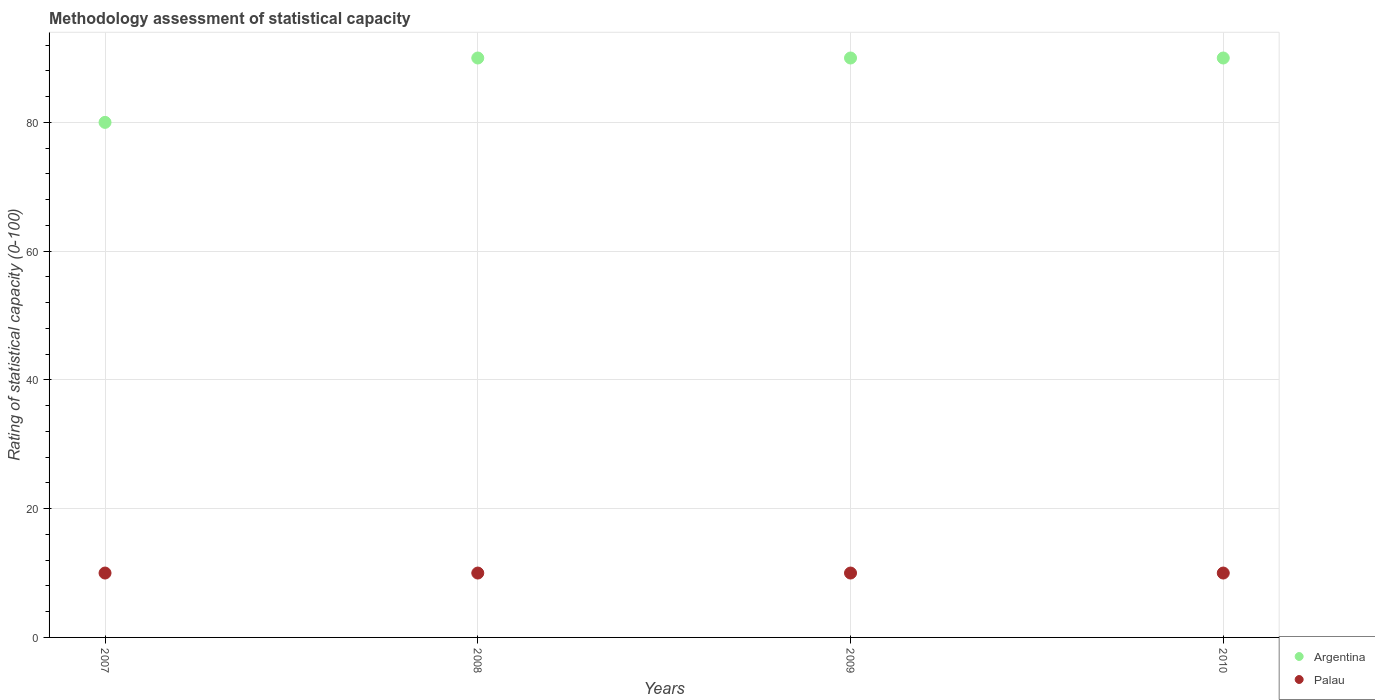How many different coloured dotlines are there?
Keep it short and to the point. 2. What is the rating of statistical capacity in Argentina in 2009?
Make the answer very short. 90. Across all years, what is the maximum rating of statistical capacity in Palau?
Your answer should be very brief. 10. In which year was the rating of statistical capacity in Palau maximum?
Your response must be concise. 2007. In which year was the rating of statistical capacity in Palau minimum?
Offer a very short reply. 2007. What is the total rating of statistical capacity in Argentina in the graph?
Offer a terse response. 350. What is the difference between the rating of statistical capacity in Argentina in 2007 and that in 2009?
Make the answer very short. -10. What is the difference between the rating of statistical capacity in Palau in 2008 and the rating of statistical capacity in Argentina in 2010?
Provide a short and direct response. -80. What is the ratio of the rating of statistical capacity in Argentina in 2007 to that in 2008?
Provide a short and direct response. 0.89. Is the difference between the rating of statistical capacity in Argentina in 2008 and 2010 greater than the difference between the rating of statistical capacity in Palau in 2008 and 2010?
Your answer should be compact. No. What is the difference between the highest and the second highest rating of statistical capacity in Palau?
Provide a short and direct response. 0. What is the difference between the highest and the lowest rating of statistical capacity in Argentina?
Offer a very short reply. 10. In how many years, is the rating of statistical capacity in Argentina greater than the average rating of statistical capacity in Argentina taken over all years?
Provide a short and direct response. 3. Is the sum of the rating of statistical capacity in Palau in 2009 and 2010 greater than the maximum rating of statistical capacity in Argentina across all years?
Provide a short and direct response. No. Is the rating of statistical capacity in Palau strictly greater than the rating of statistical capacity in Argentina over the years?
Keep it short and to the point. No. How many years are there in the graph?
Give a very brief answer. 4. What is the difference between two consecutive major ticks on the Y-axis?
Make the answer very short. 20. Are the values on the major ticks of Y-axis written in scientific E-notation?
Your answer should be compact. No. Does the graph contain any zero values?
Ensure brevity in your answer.  No. Does the graph contain grids?
Offer a very short reply. Yes. Where does the legend appear in the graph?
Your answer should be very brief. Bottom right. How are the legend labels stacked?
Provide a succinct answer. Vertical. What is the title of the graph?
Keep it short and to the point. Methodology assessment of statistical capacity. What is the label or title of the Y-axis?
Provide a short and direct response. Rating of statistical capacity (0-100). What is the Rating of statistical capacity (0-100) of Argentina in 2008?
Make the answer very short. 90. What is the Rating of statistical capacity (0-100) in Argentina in 2010?
Provide a succinct answer. 90. Across all years, what is the maximum Rating of statistical capacity (0-100) in Argentina?
Your response must be concise. 90. Across all years, what is the maximum Rating of statistical capacity (0-100) in Palau?
Your answer should be very brief. 10. Across all years, what is the minimum Rating of statistical capacity (0-100) of Argentina?
Provide a short and direct response. 80. Across all years, what is the minimum Rating of statistical capacity (0-100) of Palau?
Offer a very short reply. 10. What is the total Rating of statistical capacity (0-100) of Argentina in the graph?
Offer a very short reply. 350. What is the total Rating of statistical capacity (0-100) in Palau in the graph?
Your answer should be very brief. 40. What is the difference between the Rating of statistical capacity (0-100) in Argentina in 2007 and that in 2010?
Your response must be concise. -10. What is the difference between the Rating of statistical capacity (0-100) in Palau in 2007 and that in 2010?
Provide a succinct answer. 0. What is the difference between the Rating of statistical capacity (0-100) in Argentina in 2008 and that in 2009?
Ensure brevity in your answer.  0. What is the difference between the Rating of statistical capacity (0-100) in Palau in 2008 and that in 2009?
Provide a succinct answer. 0. What is the difference between the Rating of statistical capacity (0-100) of Argentina in 2008 and that in 2010?
Give a very brief answer. 0. What is the difference between the Rating of statistical capacity (0-100) of Palau in 2008 and that in 2010?
Your response must be concise. 0. What is the difference between the Rating of statistical capacity (0-100) of Palau in 2009 and that in 2010?
Keep it short and to the point. 0. What is the difference between the Rating of statistical capacity (0-100) of Argentina in 2007 and the Rating of statistical capacity (0-100) of Palau in 2008?
Provide a short and direct response. 70. What is the difference between the Rating of statistical capacity (0-100) in Argentina in 2007 and the Rating of statistical capacity (0-100) in Palau in 2009?
Offer a very short reply. 70. What is the difference between the Rating of statistical capacity (0-100) of Argentina in 2008 and the Rating of statistical capacity (0-100) of Palau in 2010?
Keep it short and to the point. 80. What is the average Rating of statistical capacity (0-100) in Argentina per year?
Offer a very short reply. 87.5. What is the average Rating of statistical capacity (0-100) in Palau per year?
Make the answer very short. 10. In the year 2007, what is the difference between the Rating of statistical capacity (0-100) in Argentina and Rating of statistical capacity (0-100) in Palau?
Ensure brevity in your answer.  70. In the year 2009, what is the difference between the Rating of statistical capacity (0-100) of Argentina and Rating of statistical capacity (0-100) of Palau?
Offer a very short reply. 80. What is the ratio of the Rating of statistical capacity (0-100) of Argentina in 2007 to that in 2009?
Ensure brevity in your answer.  0.89. What is the ratio of the Rating of statistical capacity (0-100) of Palau in 2007 to that in 2009?
Provide a succinct answer. 1. What is the ratio of the Rating of statistical capacity (0-100) of Argentina in 2007 to that in 2010?
Provide a short and direct response. 0.89. What is the ratio of the Rating of statistical capacity (0-100) of Argentina in 2009 to that in 2010?
Keep it short and to the point. 1. What is the difference between the highest and the second highest Rating of statistical capacity (0-100) of Argentina?
Your answer should be compact. 0. What is the difference between the highest and the lowest Rating of statistical capacity (0-100) in Argentina?
Your answer should be very brief. 10. 